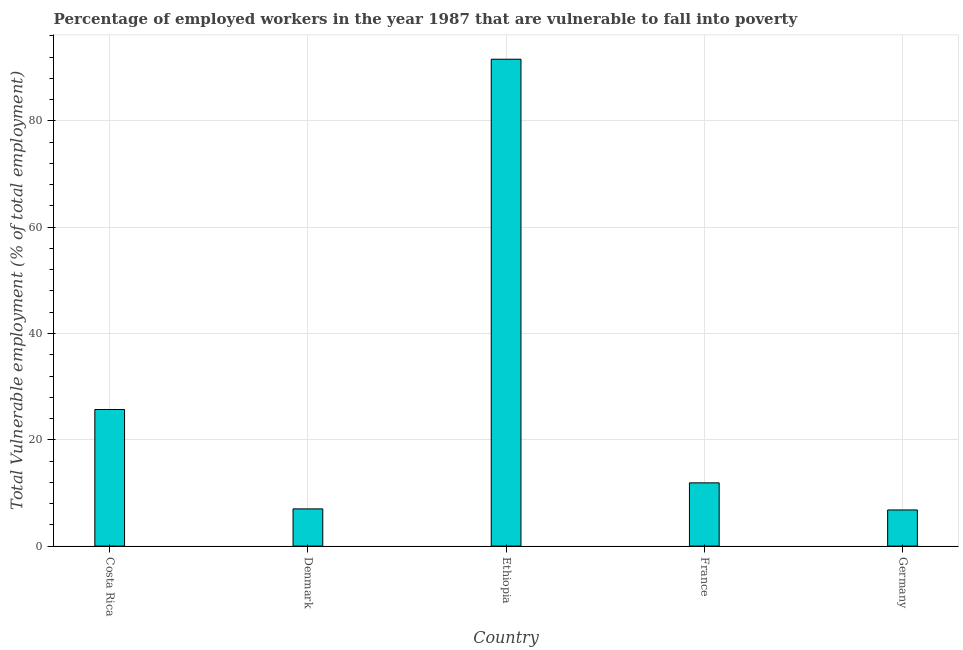Does the graph contain any zero values?
Your answer should be compact. No. What is the title of the graph?
Your response must be concise. Percentage of employed workers in the year 1987 that are vulnerable to fall into poverty. What is the label or title of the X-axis?
Provide a short and direct response. Country. What is the label or title of the Y-axis?
Offer a terse response. Total Vulnerable employment (% of total employment). Across all countries, what is the maximum total vulnerable employment?
Offer a terse response. 91.6. Across all countries, what is the minimum total vulnerable employment?
Offer a terse response. 6.8. In which country was the total vulnerable employment maximum?
Your response must be concise. Ethiopia. What is the sum of the total vulnerable employment?
Your answer should be compact. 143. What is the difference between the total vulnerable employment in Denmark and Ethiopia?
Ensure brevity in your answer.  -84.6. What is the average total vulnerable employment per country?
Keep it short and to the point. 28.6. What is the median total vulnerable employment?
Provide a short and direct response. 11.9. What is the ratio of the total vulnerable employment in Costa Rica to that in Germany?
Offer a very short reply. 3.78. Is the difference between the total vulnerable employment in Ethiopia and France greater than the difference between any two countries?
Your answer should be compact. No. What is the difference between the highest and the second highest total vulnerable employment?
Offer a very short reply. 65.9. Is the sum of the total vulnerable employment in Ethiopia and Germany greater than the maximum total vulnerable employment across all countries?
Offer a terse response. Yes. What is the difference between the highest and the lowest total vulnerable employment?
Give a very brief answer. 84.8. How many bars are there?
Make the answer very short. 5. What is the difference between two consecutive major ticks on the Y-axis?
Your response must be concise. 20. Are the values on the major ticks of Y-axis written in scientific E-notation?
Your answer should be very brief. No. What is the Total Vulnerable employment (% of total employment) in Costa Rica?
Keep it short and to the point. 25.7. What is the Total Vulnerable employment (% of total employment) in Ethiopia?
Ensure brevity in your answer.  91.6. What is the Total Vulnerable employment (% of total employment) of France?
Your answer should be compact. 11.9. What is the Total Vulnerable employment (% of total employment) in Germany?
Ensure brevity in your answer.  6.8. What is the difference between the Total Vulnerable employment (% of total employment) in Costa Rica and Ethiopia?
Give a very brief answer. -65.9. What is the difference between the Total Vulnerable employment (% of total employment) in Denmark and Ethiopia?
Provide a succinct answer. -84.6. What is the difference between the Total Vulnerable employment (% of total employment) in Ethiopia and France?
Your answer should be compact. 79.7. What is the difference between the Total Vulnerable employment (% of total employment) in Ethiopia and Germany?
Offer a terse response. 84.8. What is the ratio of the Total Vulnerable employment (% of total employment) in Costa Rica to that in Denmark?
Offer a terse response. 3.67. What is the ratio of the Total Vulnerable employment (% of total employment) in Costa Rica to that in Ethiopia?
Provide a short and direct response. 0.28. What is the ratio of the Total Vulnerable employment (% of total employment) in Costa Rica to that in France?
Ensure brevity in your answer.  2.16. What is the ratio of the Total Vulnerable employment (% of total employment) in Costa Rica to that in Germany?
Provide a succinct answer. 3.78. What is the ratio of the Total Vulnerable employment (% of total employment) in Denmark to that in Ethiopia?
Provide a short and direct response. 0.08. What is the ratio of the Total Vulnerable employment (% of total employment) in Denmark to that in France?
Your response must be concise. 0.59. What is the ratio of the Total Vulnerable employment (% of total employment) in Ethiopia to that in France?
Give a very brief answer. 7.7. What is the ratio of the Total Vulnerable employment (% of total employment) in Ethiopia to that in Germany?
Your answer should be compact. 13.47. 